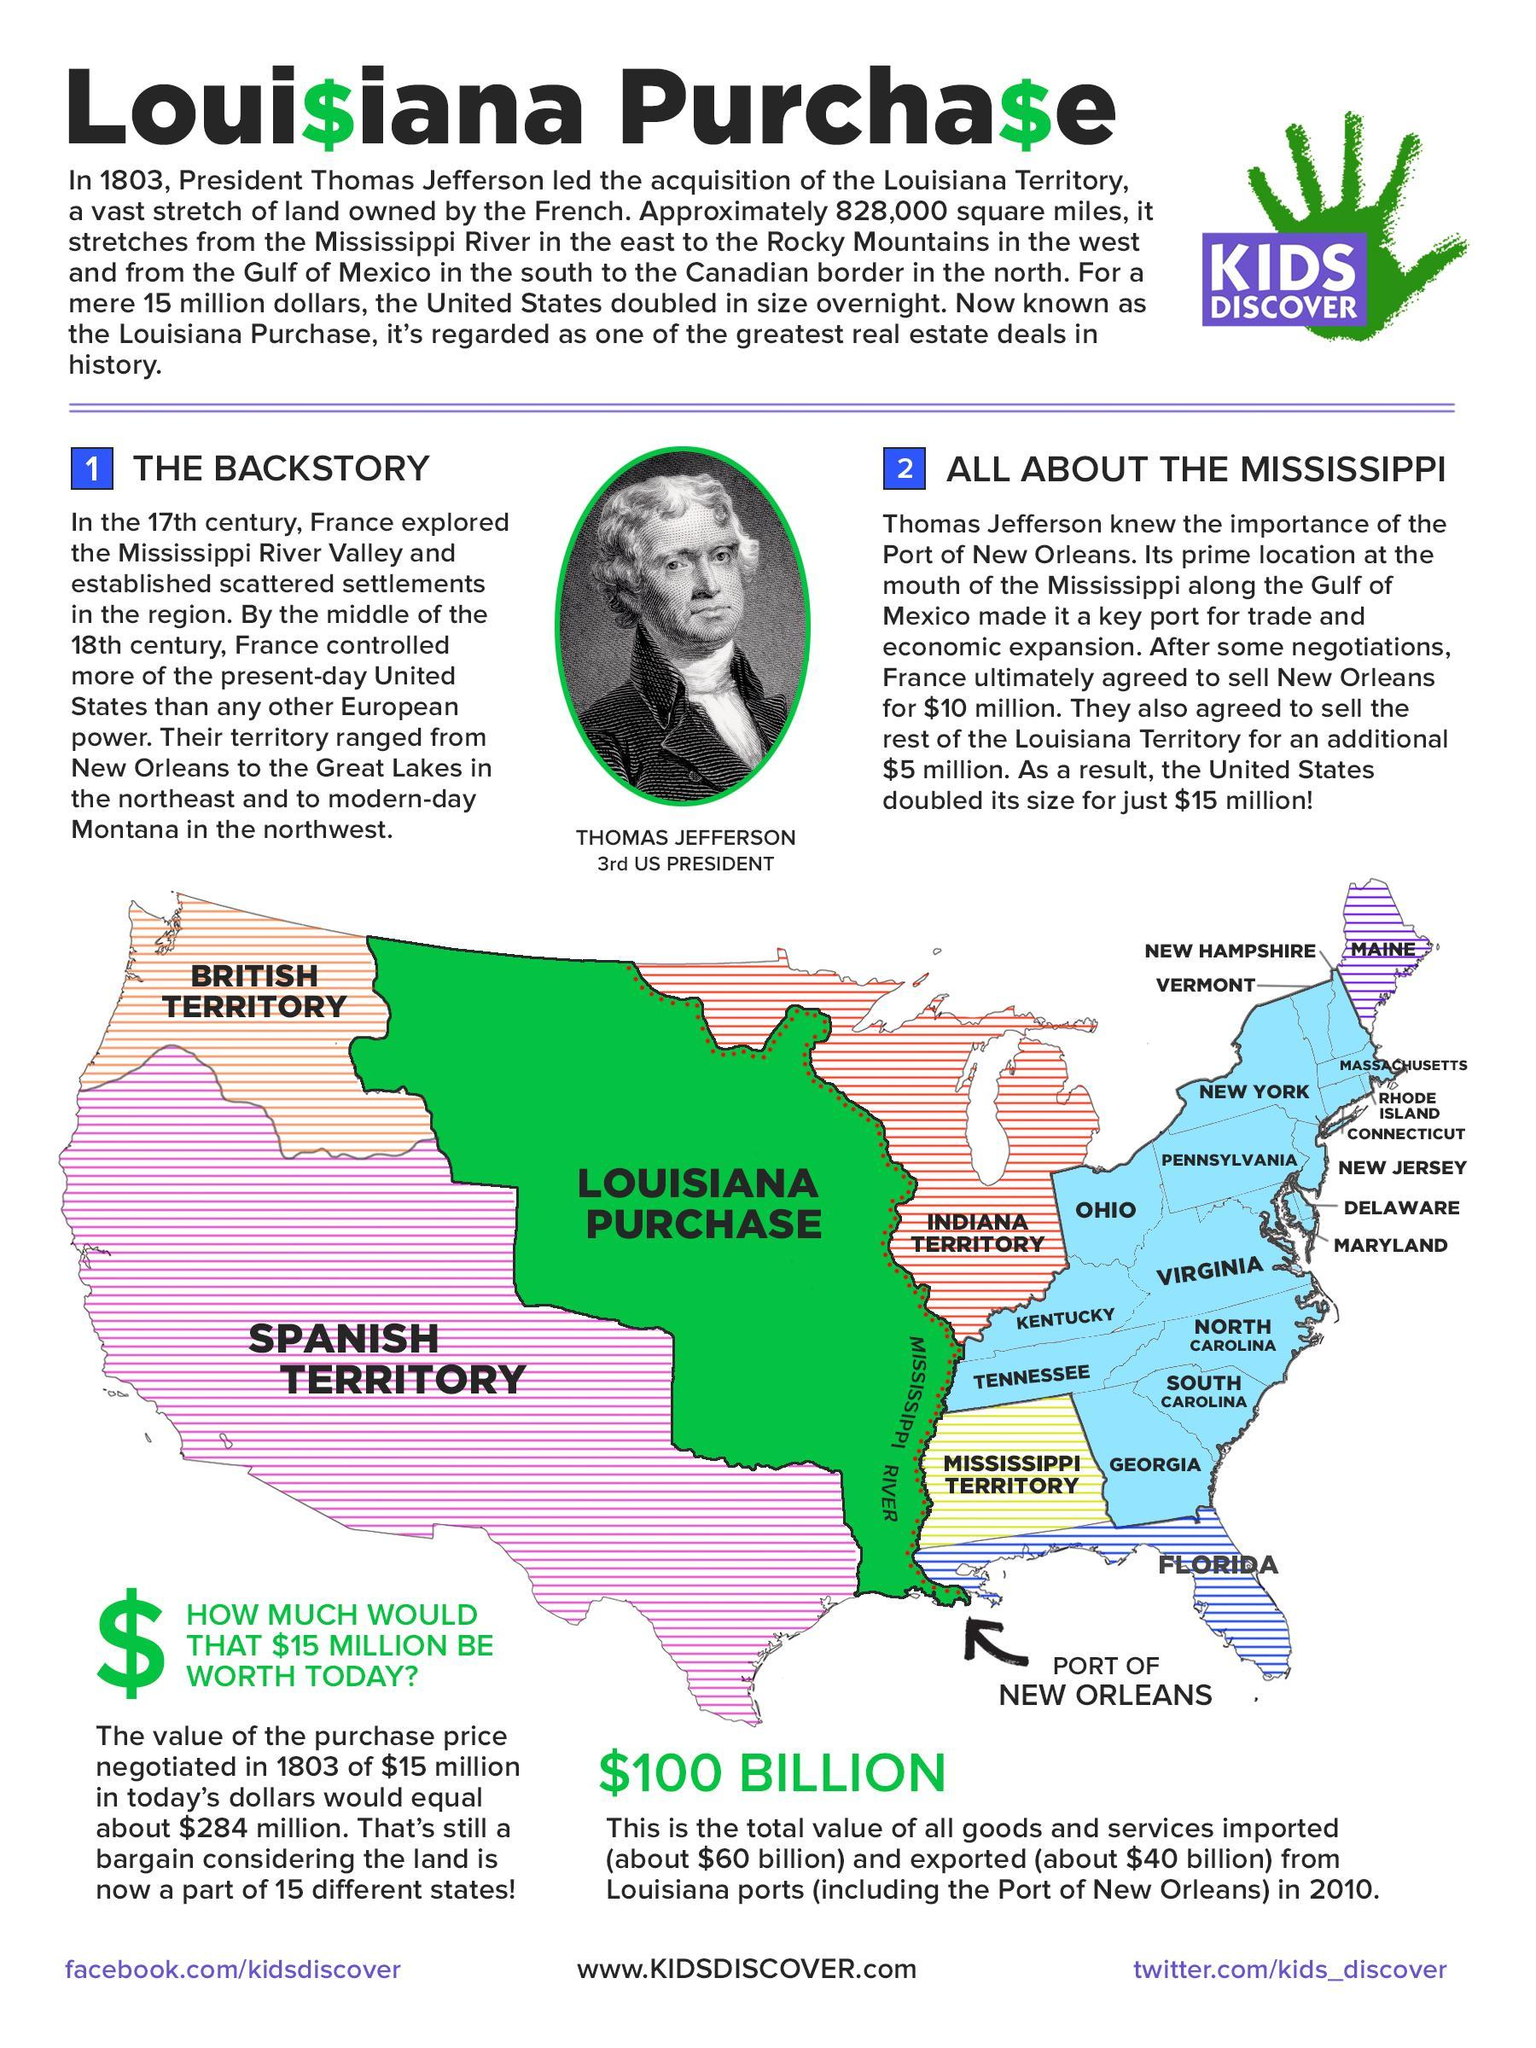What is the total value of all goods & services imported and exported from louisiana ports in 2010?
Answer the question with a short phrase. $100 Billion What is regarded as one of the greatest real estate deals in history of the U.S.? Louisiana Purchase 